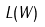Convert formula to latex. <formula><loc_0><loc_0><loc_500><loc_500>L ( W )</formula> 